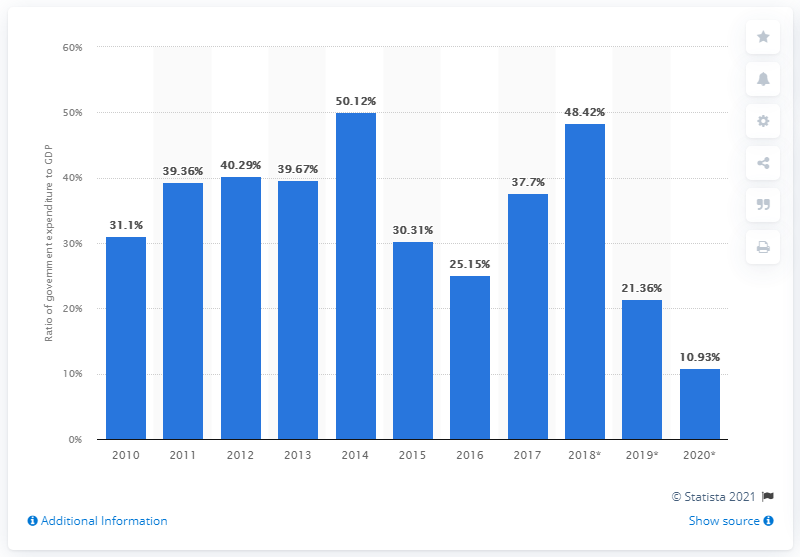List a handful of essential elements in this visual. In 2017, the Venezuelan government spent approximately 37.7% of the country's Gross Domestic Product (GDP). 